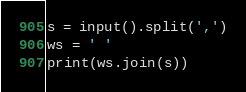Convert code to text. <code><loc_0><loc_0><loc_500><loc_500><_Python_>s = input().split(',')
ws = ' '
print(ws.join(s))</code> 